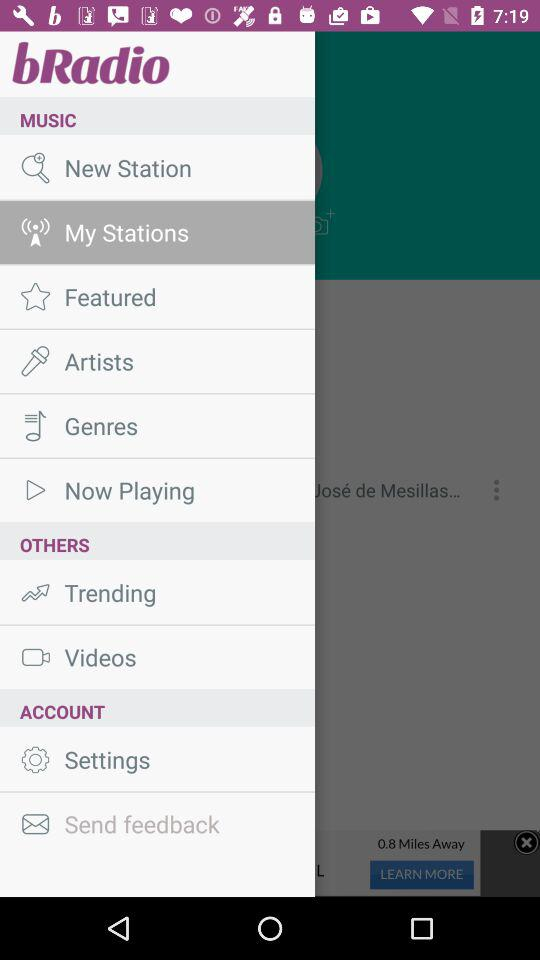What is the app name? The app name is "bRadio". 